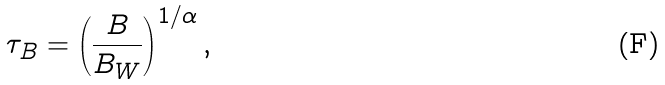<formula> <loc_0><loc_0><loc_500><loc_500>\tau _ { B } = \left ( \frac { B } { B _ { W } } \right ) ^ { 1 / \alpha } ,</formula> 